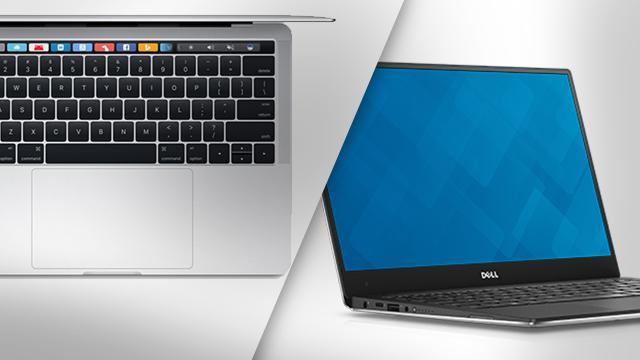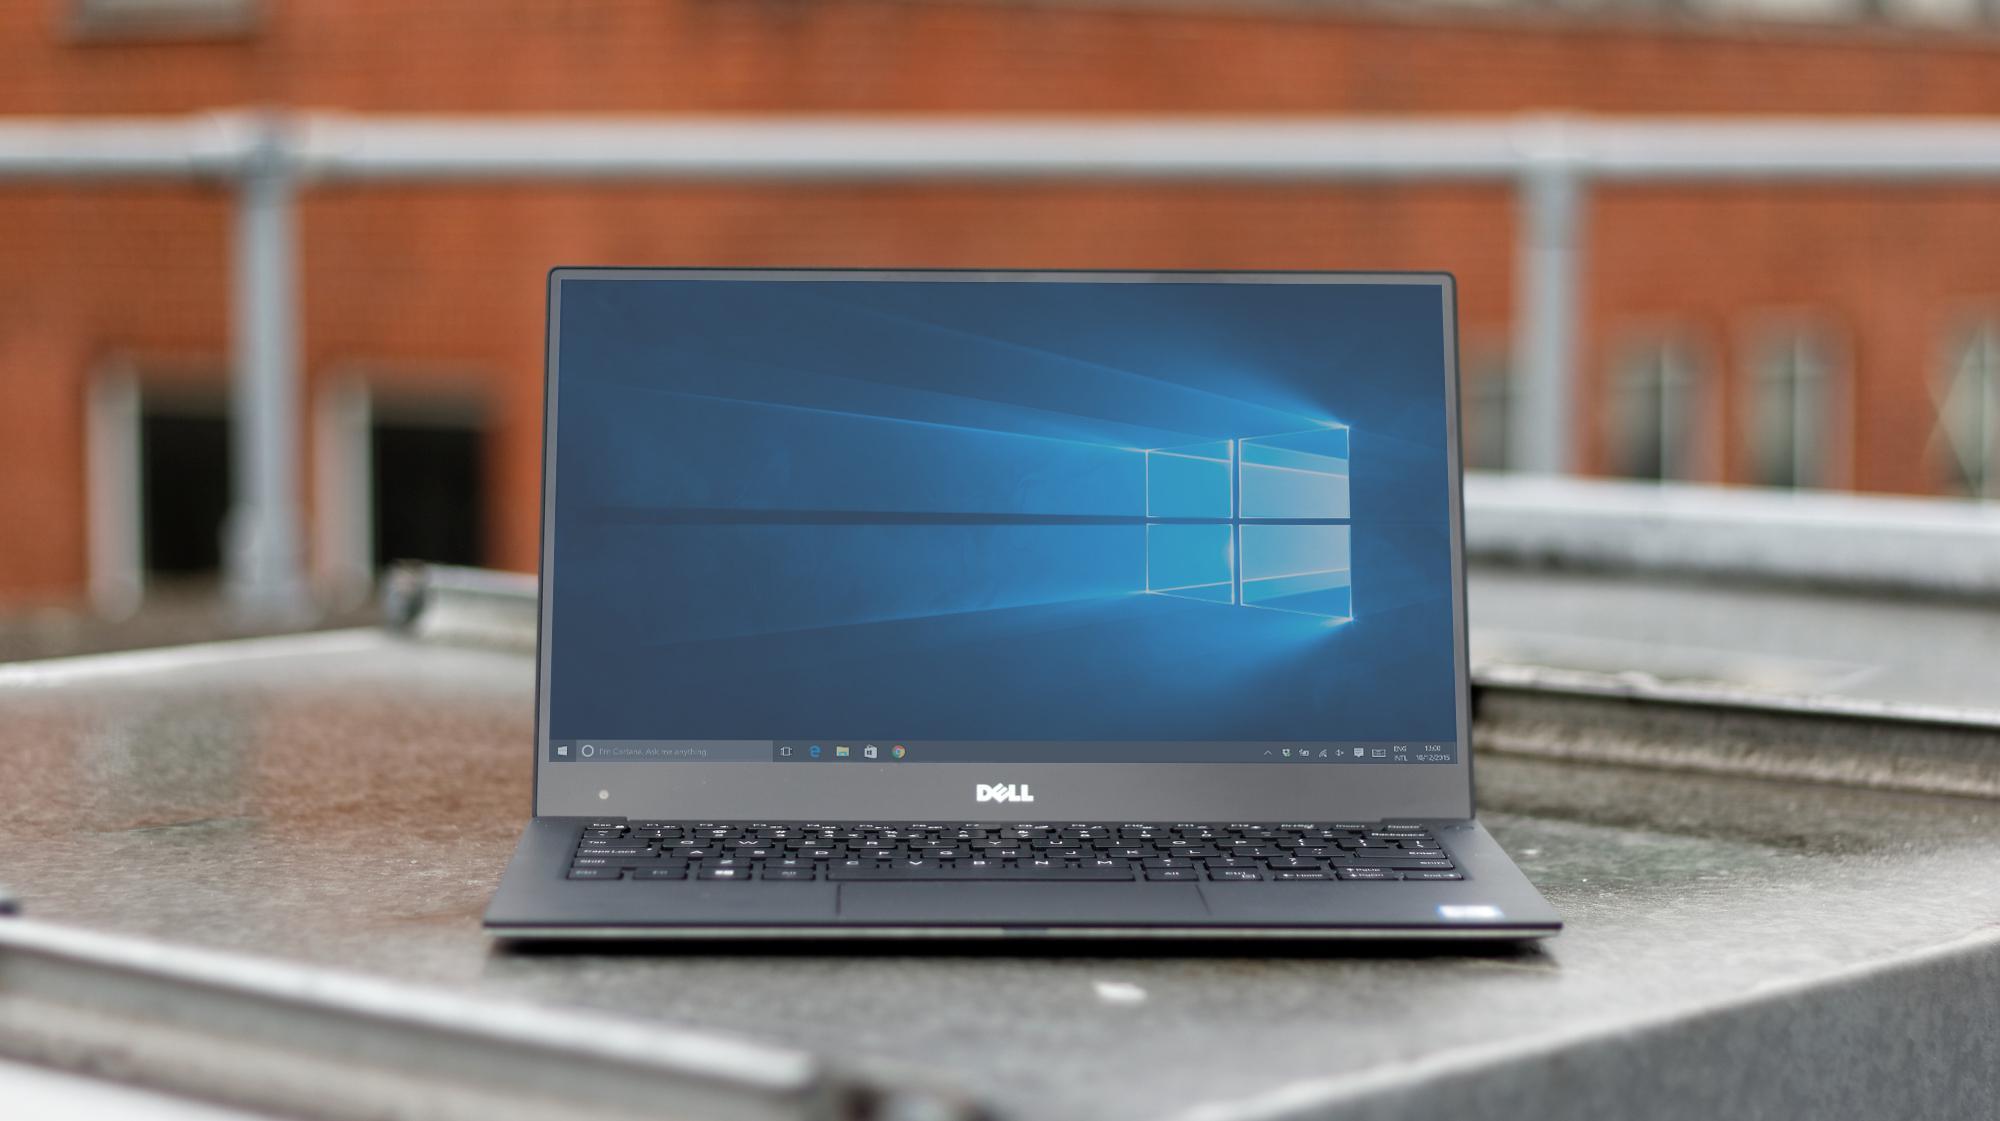The first image is the image on the left, the second image is the image on the right. Considering the images on both sides, is "In the image on the right 2 laptops are placed side by side." valid? Answer yes or no. No. The first image is the image on the left, the second image is the image on the right. For the images displayed, is the sentence "The left image features one closed laptop stacked on another, and the right image shows side-by-side open laptops." factually correct? Answer yes or no. No. 